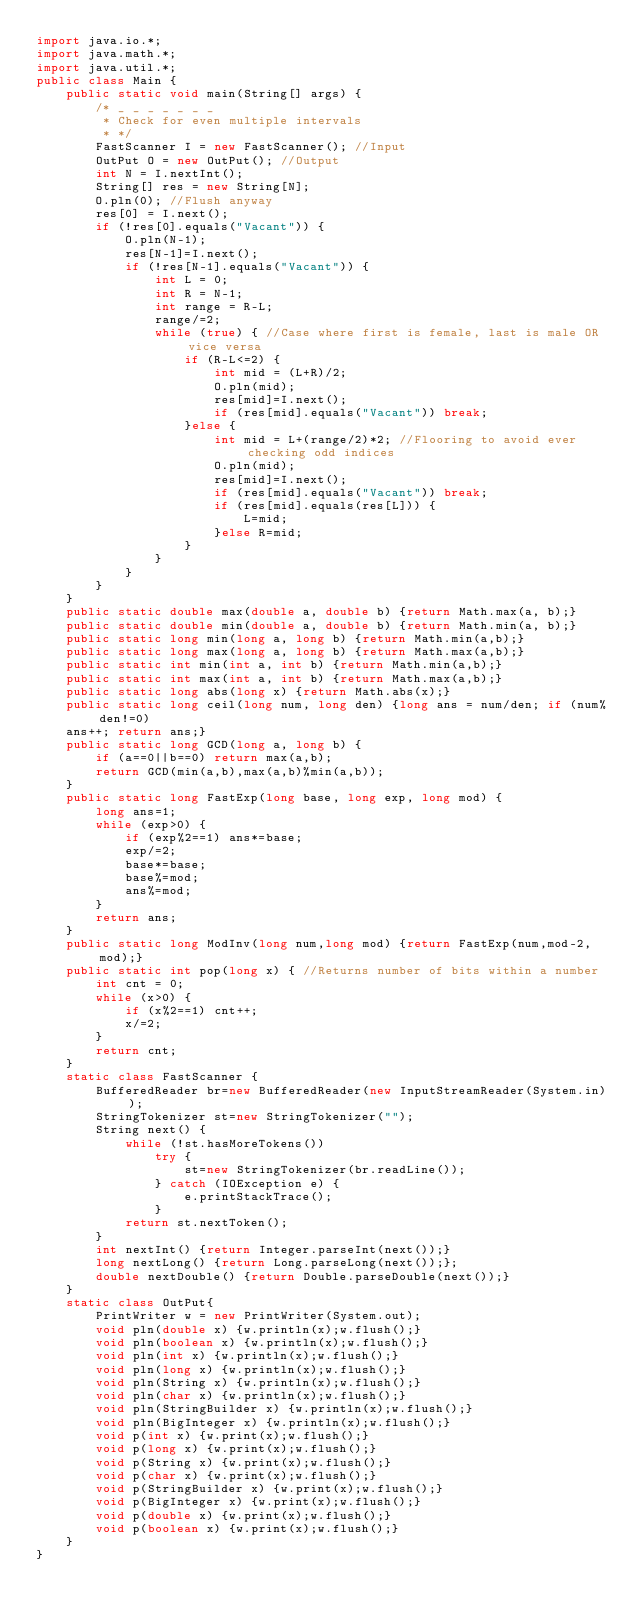<code> <loc_0><loc_0><loc_500><loc_500><_Java_>import java.io.*;
import java.math.*;
import java.util.*;
public class Main {
	public static void main(String[] args) { 
		/* _ _ _ _ _ _ _
		 * Check for even multiple intervals
		 * */
		FastScanner I = new FastScanner(); //Input
		OutPut O = new OutPut(); //Output
		int N = I.nextInt();
		String[] res = new String[N];
		O.pln(0); //Flush anyway
		res[0] = I.next();
		if (!res[0].equals("Vacant")) {
			O.pln(N-1);
			res[N-1]=I.next();
			if (!res[N-1].equals("Vacant")) {
				int L = 0;
				int R = N-1;
				int range = R-L;
				range/=2;
				while (true) { //Case where first is female, last is male OR vice versa
					if (R-L<=2) {
						int mid = (L+R)/2;
						O.pln(mid);
						res[mid]=I.next();
						if (res[mid].equals("Vacant")) break;
					}else {
						int mid = L+(range/2)*2; //Flooring to avoid ever checking odd indices
						O.pln(mid);
						res[mid]=I.next();
						if (res[mid].equals("Vacant")) break;
						if (res[mid].equals(res[L])) {
							L=mid;
						}else R=mid;
					}
				}
			}
		}
	}
	public static double max(double a, double b) {return Math.max(a, b);}
	public static double min(double a, double b) {return Math.min(a, b);}
	public static long min(long a, long b) {return Math.min(a,b);}
	public static long max(long a, long b) {return Math.max(a,b);}
	public static int min(int a, int b) {return Math.min(a,b);}
	public static int max(int a, int b) {return Math.max(a,b);}
	public static long abs(long x) {return Math.abs(x);}
	public static long ceil(long num, long den) {long ans = num/den; if (num%den!=0) 
	ans++; return ans;}
	public static long GCD(long a, long b) {
		if (a==0||b==0) return max(a,b);
		return GCD(min(a,b),max(a,b)%min(a,b));
	}
	public static long FastExp(long base, long exp, long mod) {
		long ans=1;
		while (exp>0) {
			if (exp%2==1) ans*=base;
			exp/=2;
			base*=base;
			base%=mod;
			ans%=mod;
		}
		return ans;
	}
	public static long ModInv(long num,long mod) {return FastExp(num,mod-2,mod);}
	public static int pop(long x) { //Returns number of bits within a number
		int cnt = 0;
		while (x>0) {
			if (x%2==1) cnt++;
			x/=2;
		}
		return cnt;
	}
	static class FastScanner {
		BufferedReader br=new BufferedReader(new InputStreamReader(System.in));
		StringTokenizer st=new StringTokenizer("");
		String next() {
			while (!st.hasMoreTokens())
				try {
					st=new StringTokenizer(br.readLine());
				} catch (IOException e) {
					e.printStackTrace();
				}
			return st.nextToken();
		}
		int nextInt() {return Integer.parseInt(next());}
		long nextLong() {return Long.parseLong(next());};
		double nextDouble() {return Double.parseDouble(next());}
	}
	static class OutPut{
		PrintWriter w = new PrintWriter(System.out);
		void pln(double x) {w.println(x);w.flush();}
		void pln(boolean x) {w.println(x);w.flush();}
		void pln(int x) {w.println(x);w.flush();}
		void pln(long x) {w.println(x);w.flush();}
		void pln(String x) {w.println(x);w.flush();}
		void pln(char x) {w.println(x);w.flush();}
		void pln(StringBuilder x) {w.println(x);w.flush();}
		void pln(BigInteger x) {w.println(x);w.flush();}
		void p(int x) {w.print(x);w.flush();}
		void p(long x) {w.print(x);w.flush();}
		void p(String x) {w.print(x);w.flush();}
		void p(char x) {w.print(x);w.flush();}
		void p(StringBuilder x) {w.print(x);w.flush();}
		void p(BigInteger x) {w.print(x);w.flush();}
		void p(double x) {w.print(x);w.flush();}
		void p(boolean x) {w.print(x);w.flush();}
	}
}
</code> 